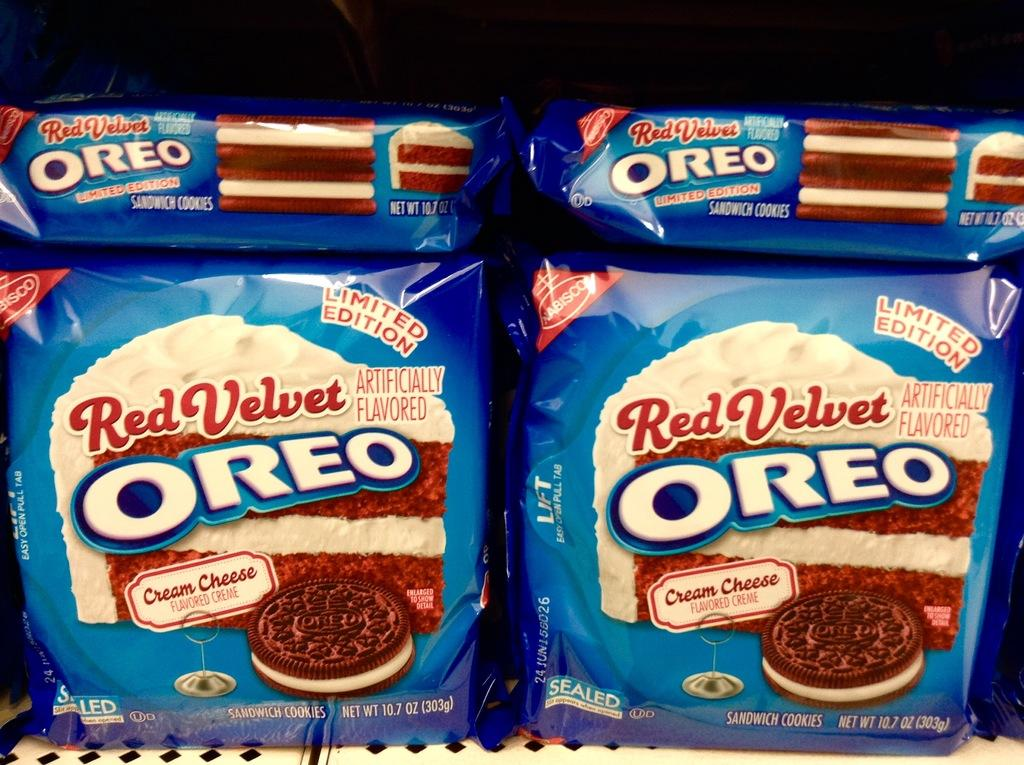What is the main subject of the image? The main subject of the image is packets arranged on a shelf. Can you describe the background of the image? The background of the image is dark in color. What type of plot is being developed in the image? There is no plot present in the image, as it features packets arranged on a shelf and a dark background. How many books can be seen in the image? There are no books visible in the image. 